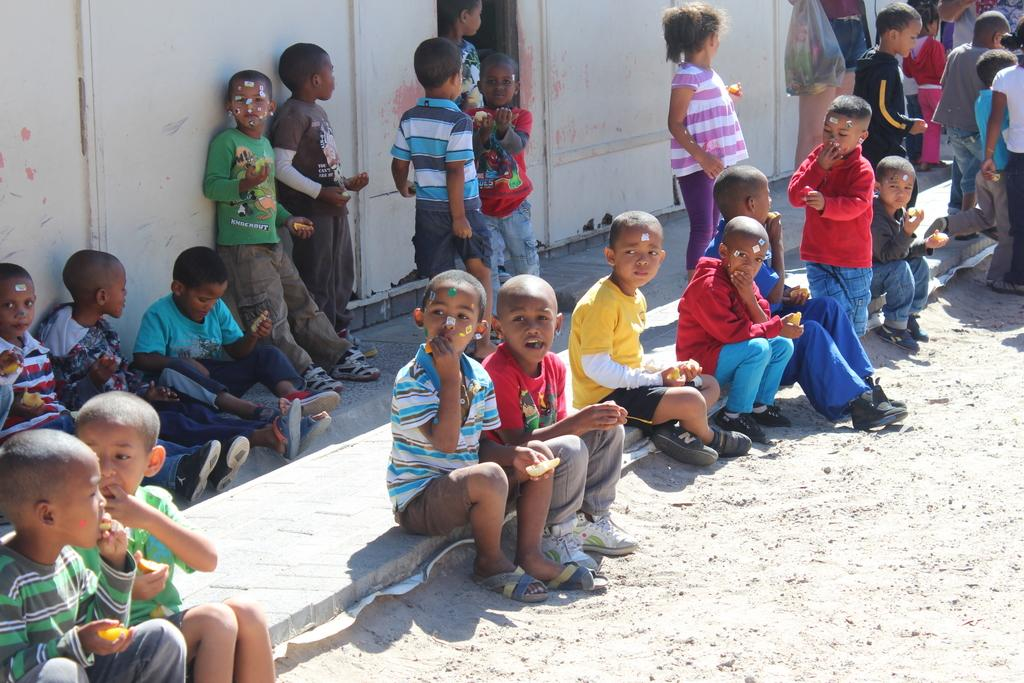What are the people in the image doing with the objects they are holding? The specific actions of the people holding objects cannot be determined from the provided facts. How are the people in the image positioned in relation to each other? Some people are sitting, while others are standing. What can be seen in the background of the image? There is a wall visible in the image. What is the surface on which the people are standing or sitting? The ground is visible in the image. What type of owl can be seen perched on the wall in the image? There is no owl present in the image; only people holding objects, sitting and standing positions, a wall, and the ground are visible. 